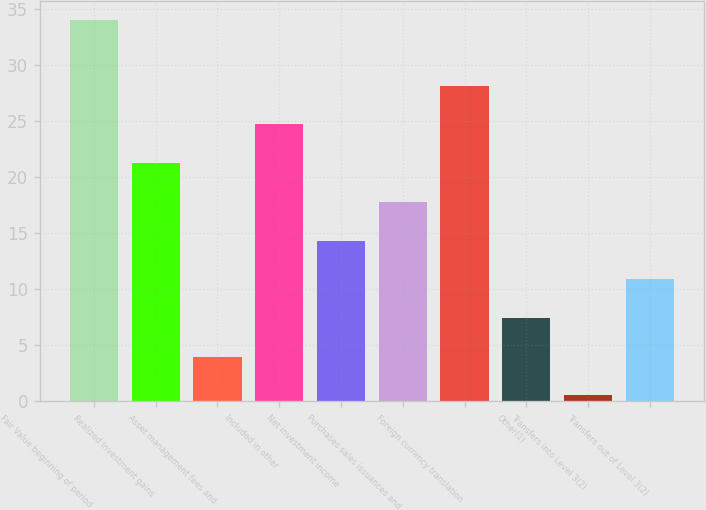<chart> <loc_0><loc_0><loc_500><loc_500><bar_chart><fcel>Fair Value beginning of period<fcel>Realized investment gains<fcel>Asset management fees and<fcel>Included in other<fcel>Net investment income<fcel>Purchases sales issuances and<fcel>Foreign currency translation<fcel>Other(1)<fcel>Transfers into Level 3(2)<fcel>Transfers out of Level 3(2)<nl><fcel>34<fcel>21.24<fcel>3.99<fcel>24.69<fcel>14.34<fcel>17.79<fcel>28.14<fcel>7.44<fcel>0.54<fcel>10.89<nl></chart> 